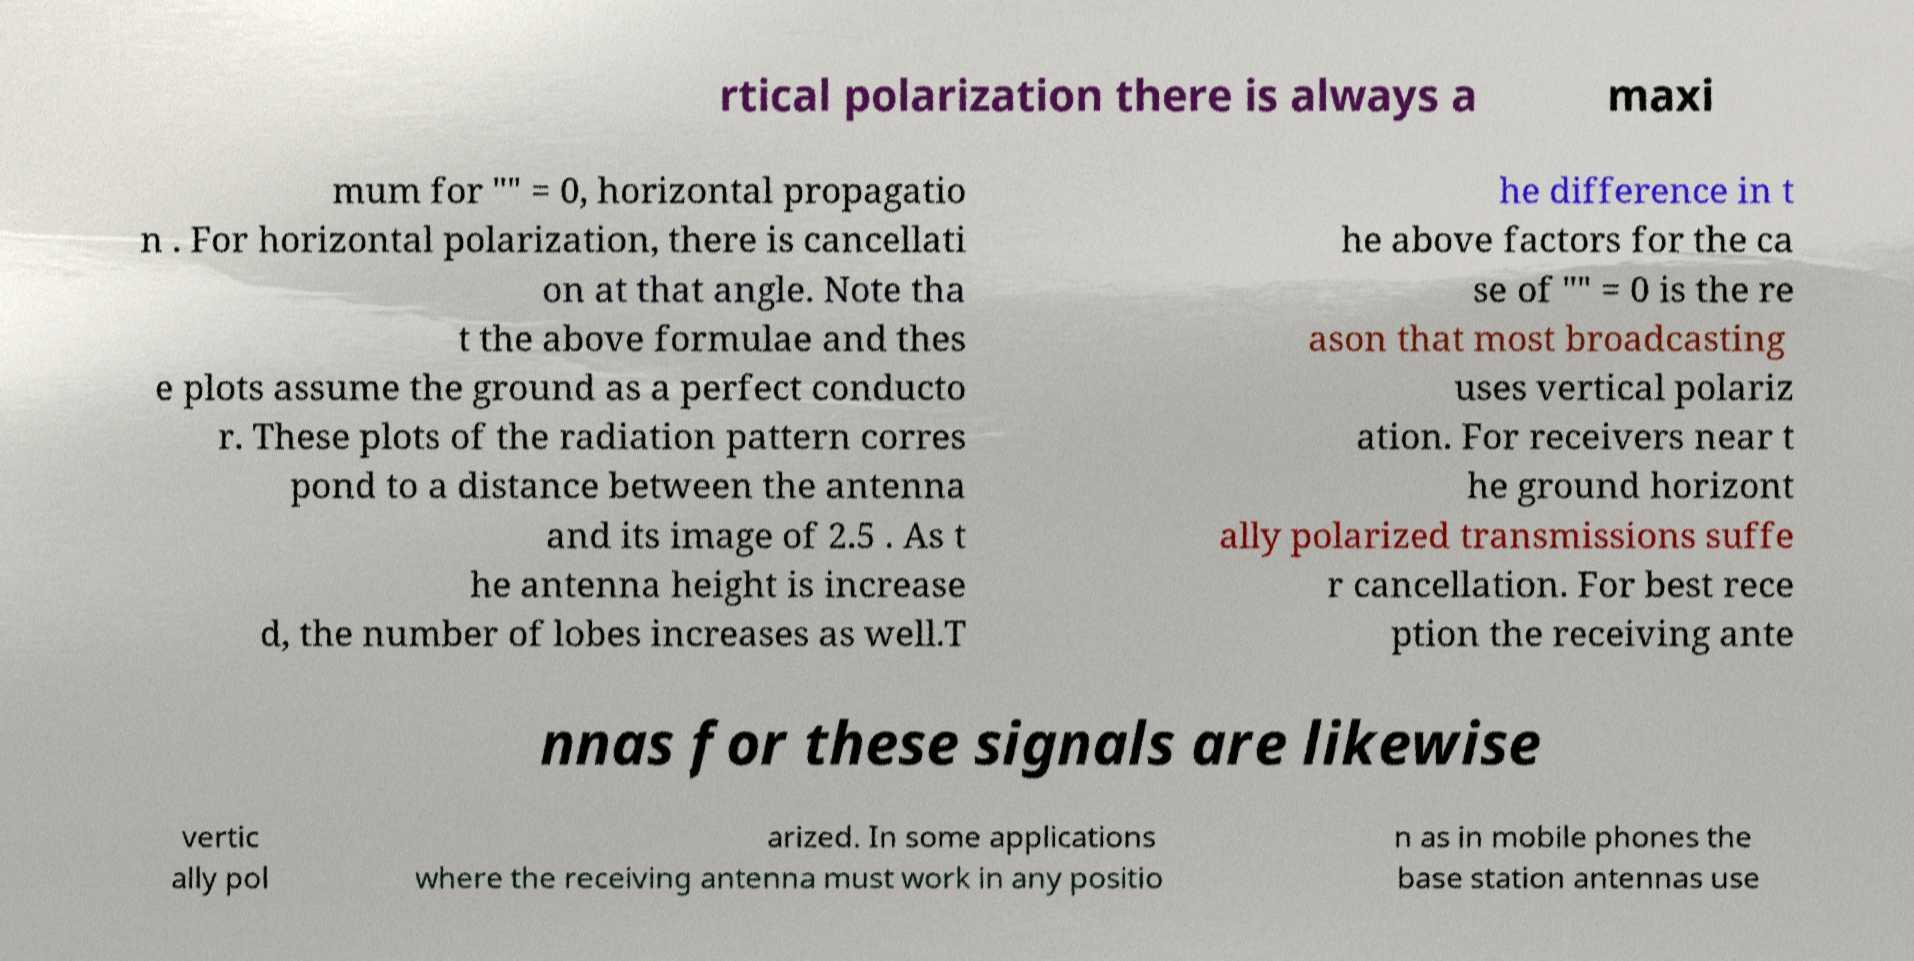What messages or text are displayed in this image? I need them in a readable, typed format. rtical polarization there is always a maxi mum for "" = 0, horizontal propagatio n . For horizontal polarization, there is cancellati on at that angle. Note tha t the above formulae and thes e plots assume the ground as a perfect conducto r. These plots of the radiation pattern corres pond to a distance between the antenna and its image of 2.5 . As t he antenna height is increase d, the number of lobes increases as well.T he difference in t he above factors for the ca se of "" = 0 is the re ason that most broadcasting uses vertical polariz ation. For receivers near t he ground horizont ally polarized transmissions suffe r cancellation. For best rece ption the receiving ante nnas for these signals are likewise vertic ally pol arized. In some applications where the receiving antenna must work in any positio n as in mobile phones the base station antennas use 